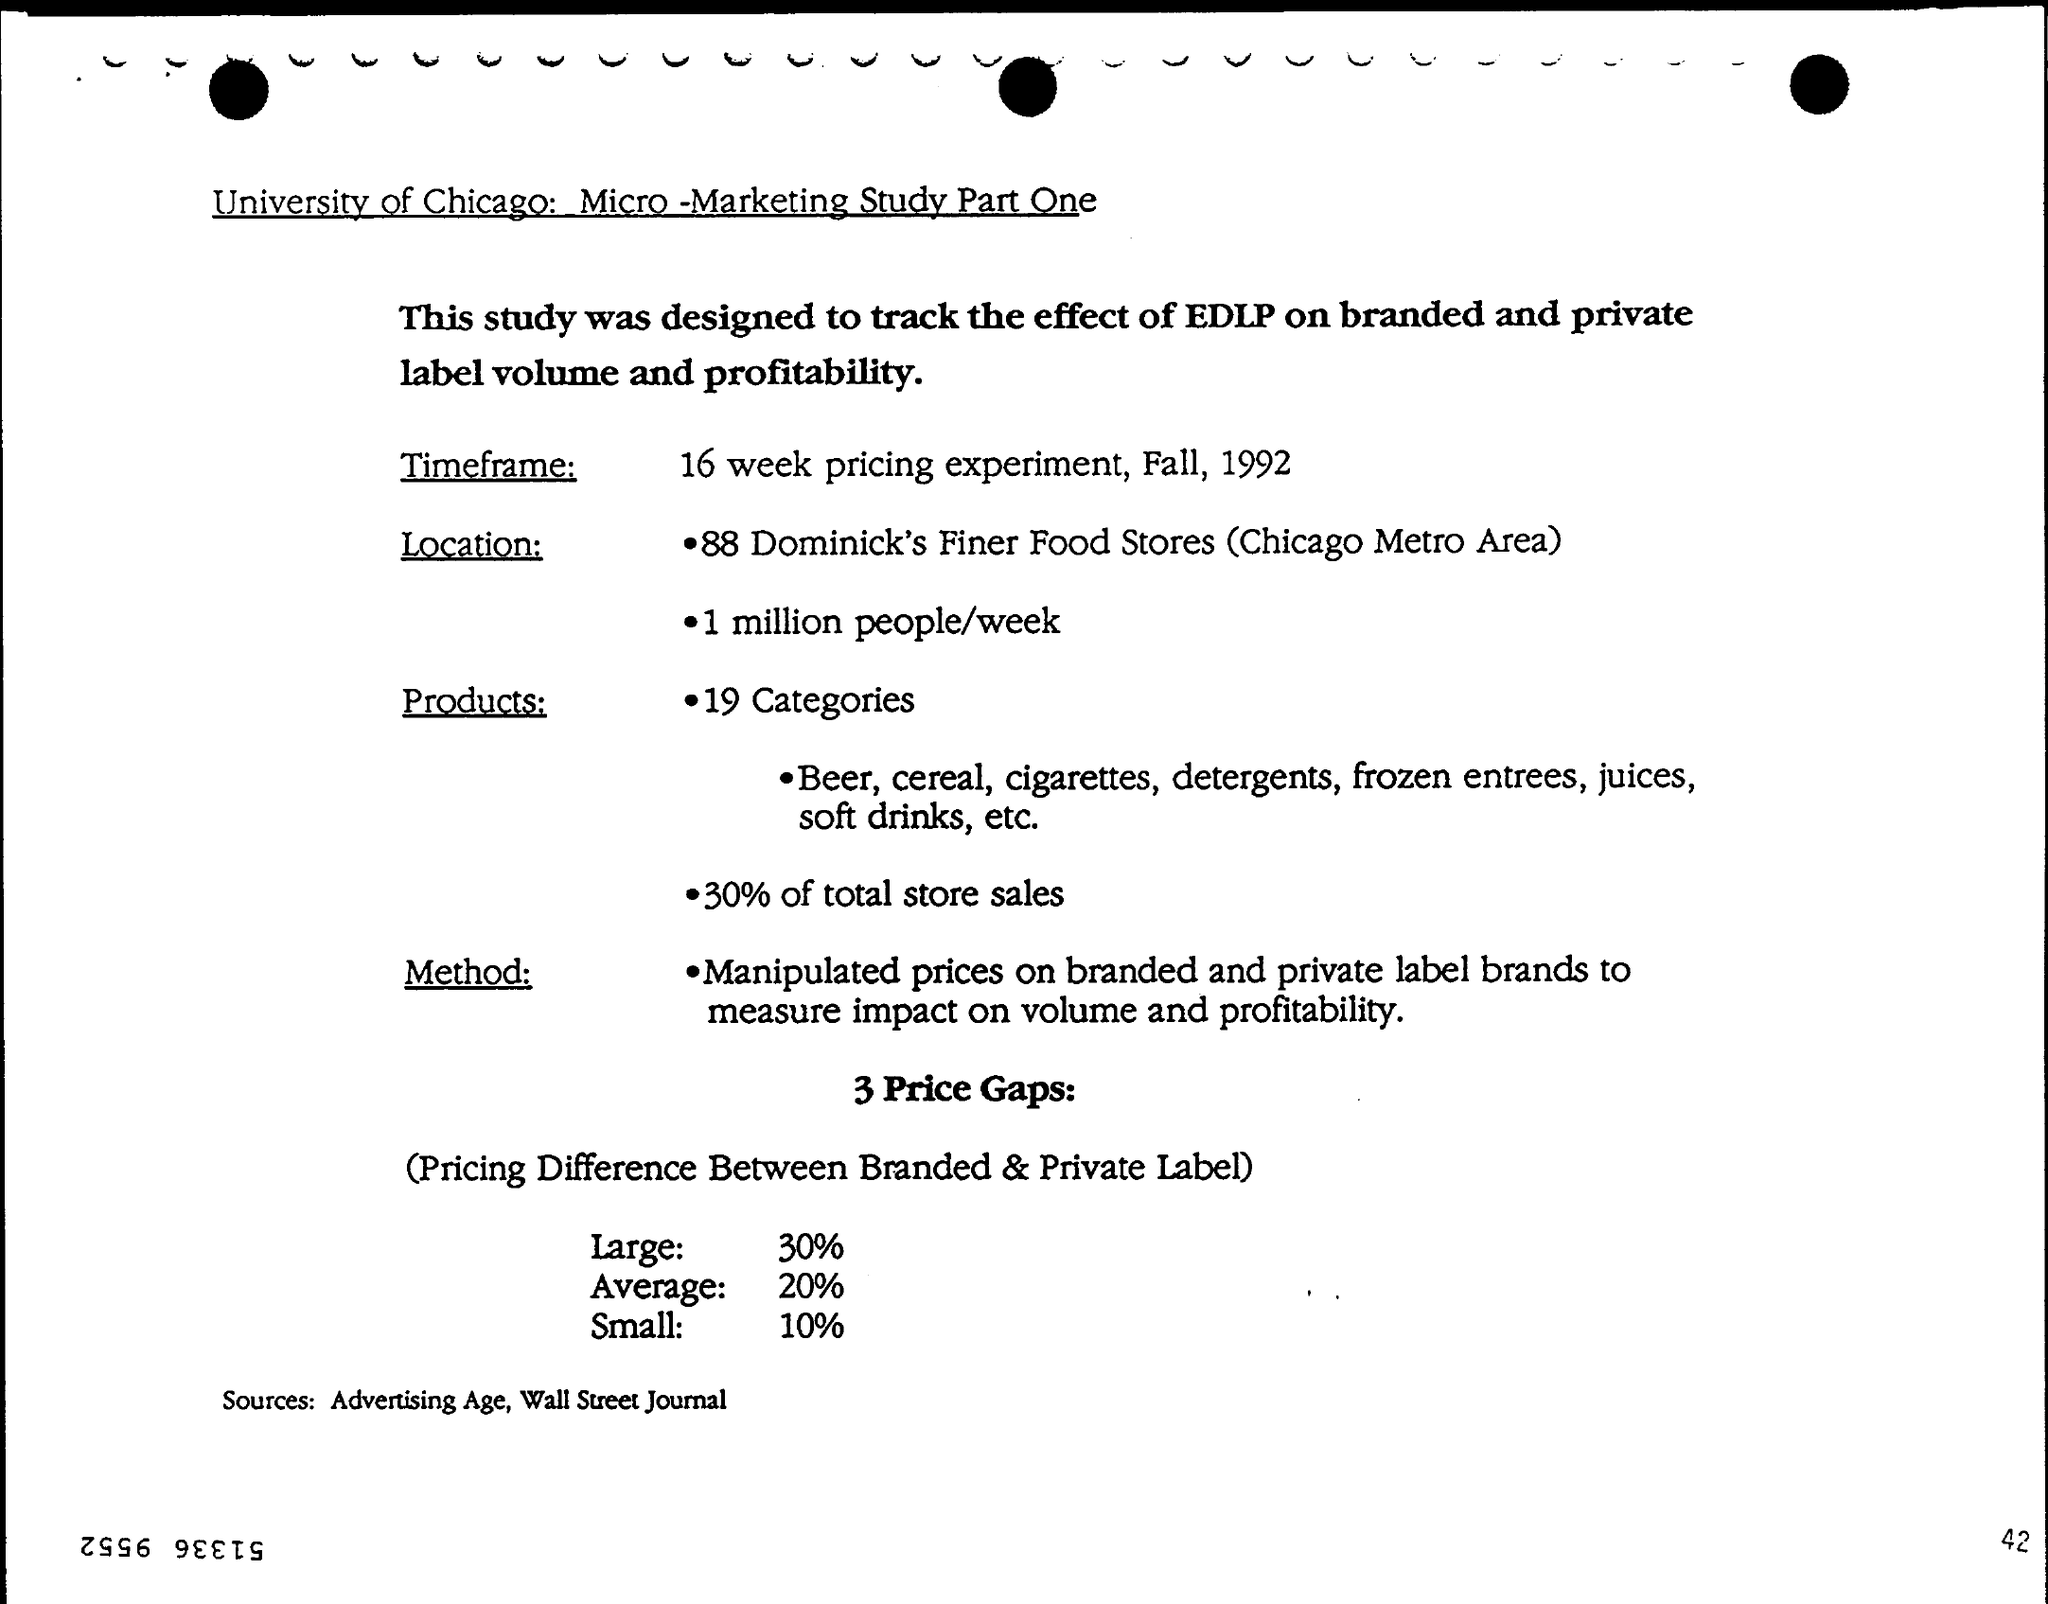What is the title of the document?
Your response must be concise. University of Chicago: Micro-Marketing Study Part One. What is the Page Number?
Make the answer very short. 42. 